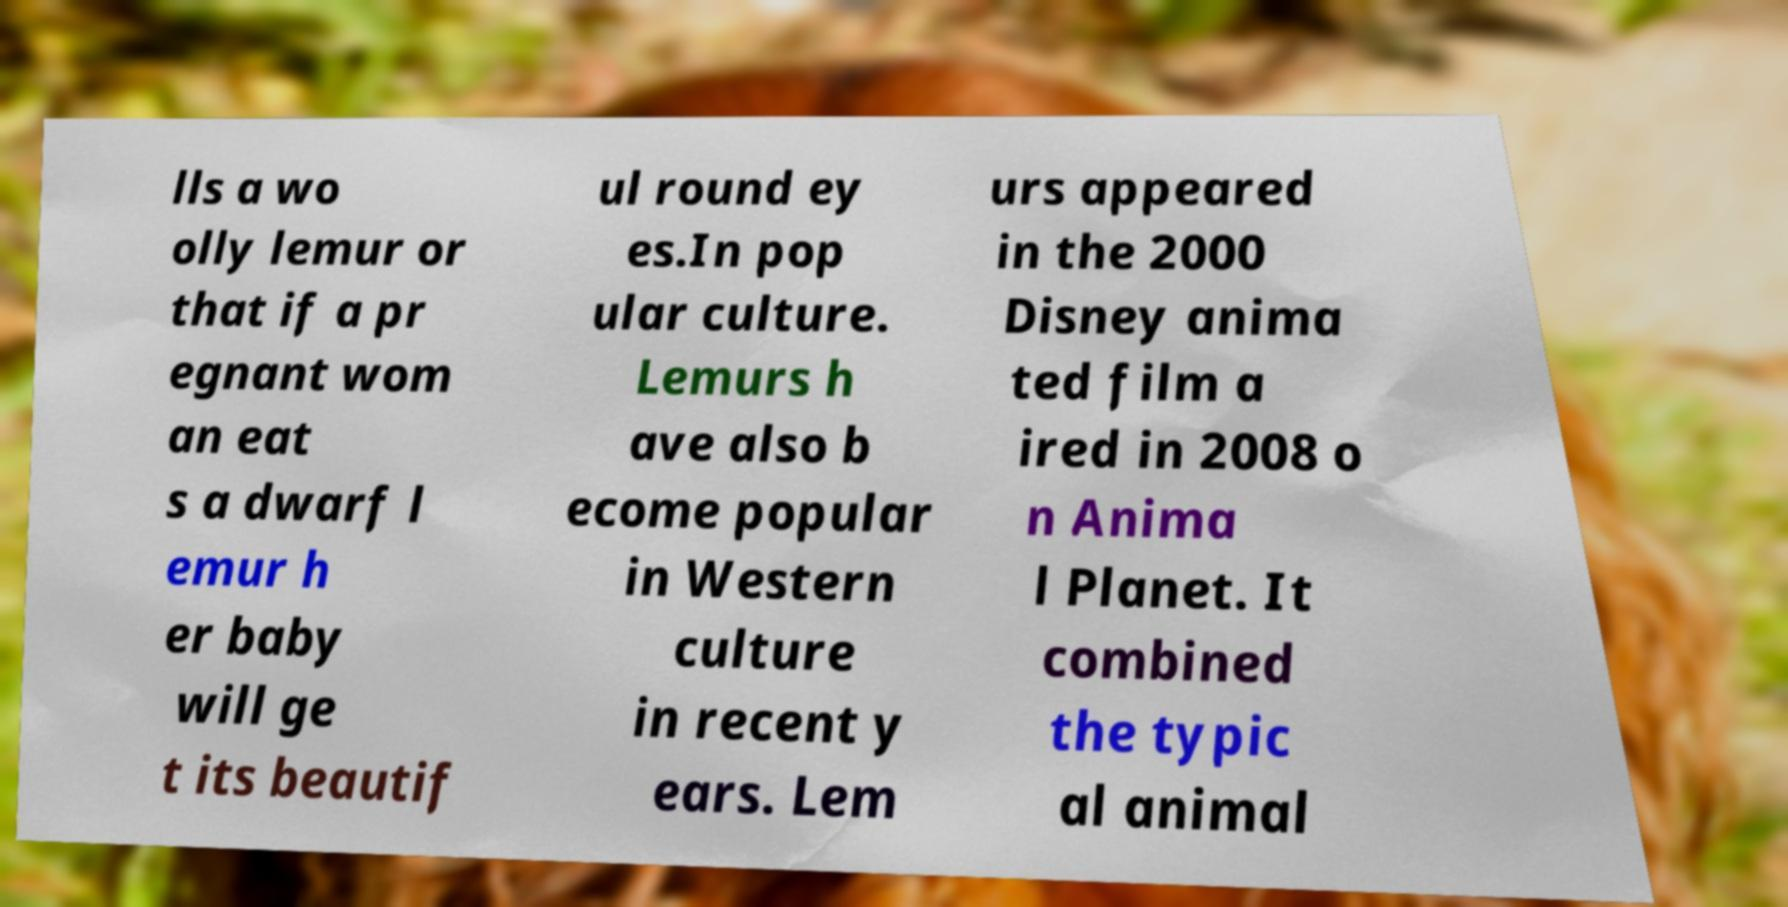For documentation purposes, I need the text within this image transcribed. Could you provide that? lls a wo olly lemur or that if a pr egnant wom an eat s a dwarf l emur h er baby will ge t its beautif ul round ey es.In pop ular culture. Lemurs h ave also b ecome popular in Western culture in recent y ears. Lem urs appeared in the 2000 Disney anima ted film a ired in 2008 o n Anima l Planet. It combined the typic al animal 